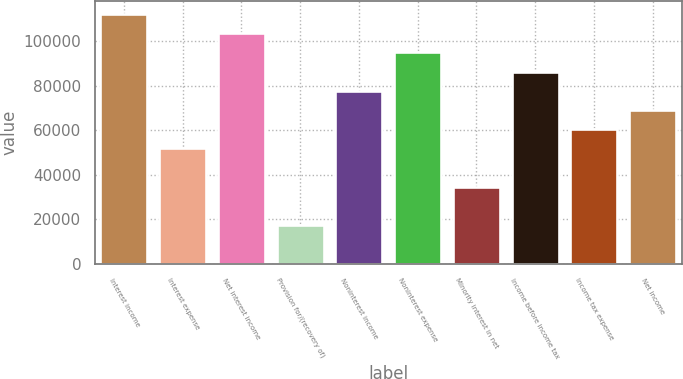Convert chart. <chart><loc_0><loc_0><loc_500><loc_500><bar_chart><fcel>Interest income<fcel>Interest expense<fcel>Net interest income<fcel>Provision for/(recovery of)<fcel>Noninterest income<fcel>Noninterest expense<fcel>Minority interest in net<fcel>Income before income tax<fcel>Income tax expense<fcel>Net income<nl><fcel>112380<fcel>51867.8<fcel>103735<fcel>17289.7<fcel>77801.4<fcel>95090.5<fcel>34578.8<fcel>86446<fcel>60512.4<fcel>69156.9<nl></chart> 